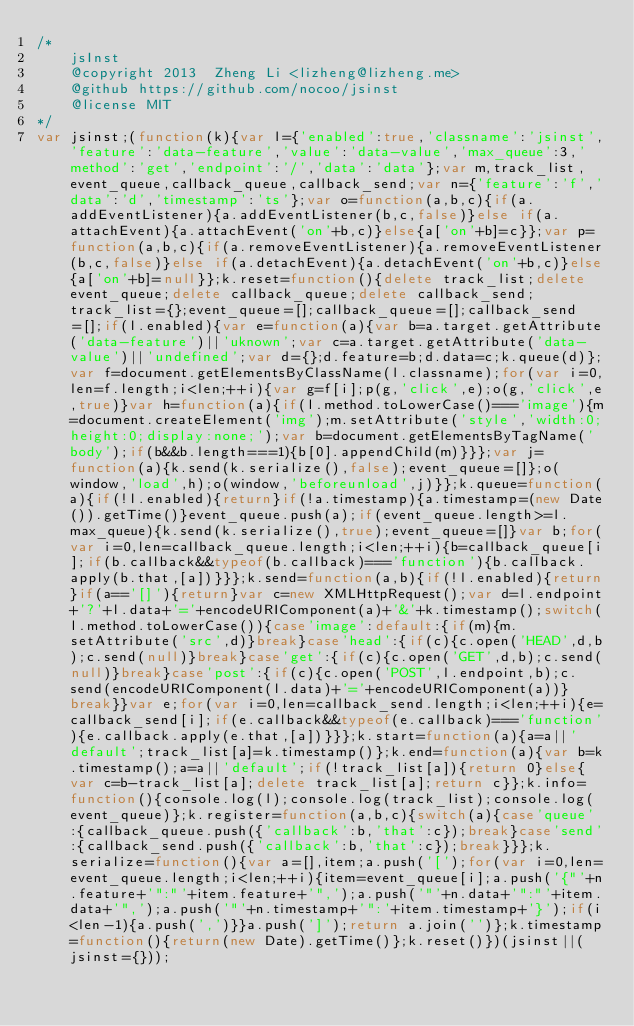<code> <loc_0><loc_0><loc_500><loc_500><_JavaScript_>/*
    jsInst
    @copyright 2013  Zheng Li <lizheng@lizheng.me>
    @github https://github.com/nocoo/jsinst
    @license MIT
*/
var jsinst;(function(k){var l={'enabled':true,'classname':'jsinst','feature':'data-feature','value':'data-value','max_queue':3,'method':'get','endpoint':'/','data':'data'};var m,track_list,event_queue,callback_queue,callback_send;var n={'feature':'f','data':'d','timestamp':'ts'};var o=function(a,b,c){if(a.addEventListener){a.addEventListener(b,c,false)}else if(a.attachEvent){a.attachEvent('on'+b,c)}else{a['on'+b]=c}};var p=function(a,b,c){if(a.removeEventListener){a.removeEventListener(b,c,false)}else if(a.detachEvent){a.detachEvent('on'+b,c)}else{a['on'+b]=null}};k.reset=function(){delete track_list;delete event_queue;delete callback_queue;delete callback_send;track_list={};event_queue=[];callback_queue=[];callback_send=[];if(l.enabled){var e=function(a){var b=a.target.getAttribute('data-feature')||'uknown';var c=a.target.getAttribute('data-value')||'undefined';var d={};d.feature=b;d.data=c;k.queue(d)};var f=document.getElementsByClassName(l.classname);for(var i=0,len=f.length;i<len;++i){var g=f[i];p(g,'click',e);o(g,'click',e,true)}var h=function(a){if(l.method.toLowerCase()==='image'){m=document.createElement('img');m.setAttribute('style','width:0;height:0;display:none;');var b=document.getElementsByTagName('body');if(b&&b.length===1){b[0].appendChild(m)}}};var j=function(a){k.send(k.serialize(),false);event_queue=[]};o(window,'load',h);o(window,'beforeunload',j)}};k.queue=function(a){if(!l.enabled){return}if(!a.timestamp){a.timestamp=(new Date()).getTime()}event_queue.push(a);if(event_queue.length>=l.max_queue){k.send(k.serialize(),true);event_queue=[]}var b;for(var i=0,len=callback_queue.length;i<len;++i){b=callback_queue[i];if(b.callback&&typeof(b.callback)==='function'){b.callback.apply(b.that,[a])}}};k.send=function(a,b){if(!l.enabled){return}if(a=='[]'){return}var c=new XMLHttpRequest();var d=l.endpoint+'?'+l.data+'='+encodeURIComponent(a)+'&'+k.timestamp();switch(l.method.toLowerCase()){case'image':default:{if(m){m.setAttribute('src',d)}break}case'head':{if(c){c.open('HEAD',d,b);c.send(null)}break}case'get':{if(c){c.open('GET',d,b);c.send(null)}break}case'post':{if(c){c.open('POST',l.endpoint,b);c.send(encodeURIComponent(l.data)+'='+encodeURIComponent(a))}break}}var e;for(var i=0,len=callback_send.length;i<len;++i){e=callback_send[i];if(e.callback&&typeof(e.callback)==='function'){e.callback.apply(e.that,[a])}}};k.start=function(a){a=a||'default';track_list[a]=k.timestamp()};k.end=function(a){var b=k.timestamp();a=a||'default';if(!track_list[a]){return 0}else{var c=b-track_list[a];delete track_list[a];return c}};k.info=function(){console.log(l);console.log(track_list);console.log(event_queue)};k.register=function(a,b,c){switch(a){case'queue':{callback_queue.push({'callback':b,'that':c});break}case'send':{callback_send.push({'callback':b,'that':c});break}}};k.serialize=function(){var a=[],item;a.push('[');for(var i=0,len=event_queue.length;i<len;++i){item=event_queue[i];a.push('{"'+n.feature+'":"'+item.feature+'",');a.push('"'+n.data+'":"'+item.data+'",');a.push('"'+n.timestamp+'":'+item.timestamp+'}');if(i<len-1){a.push(',')}}a.push(']');return a.join('')};k.timestamp=function(){return(new Date).getTime()};k.reset()})(jsinst||(jsinst={}));
</code> 